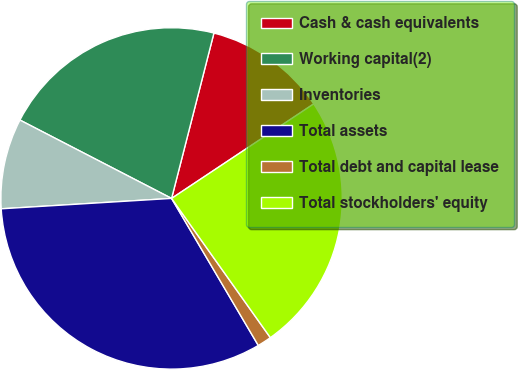<chart> <loc_0><loc_0><loc_500><loc_500><pie_chart><fcel>Cash & cash equivalents<fcel>Working capital(2)<fcel>Inventories<fcel>Total assets<fcel>Total debt and capital lease<fcel>Total stockholders' equity<nl><fcel>11.67%<fcel>21.4%<fcel>8.56%<fcel>32.51%<fcel>1.34%<fcel>24.52%<nl></chart> 